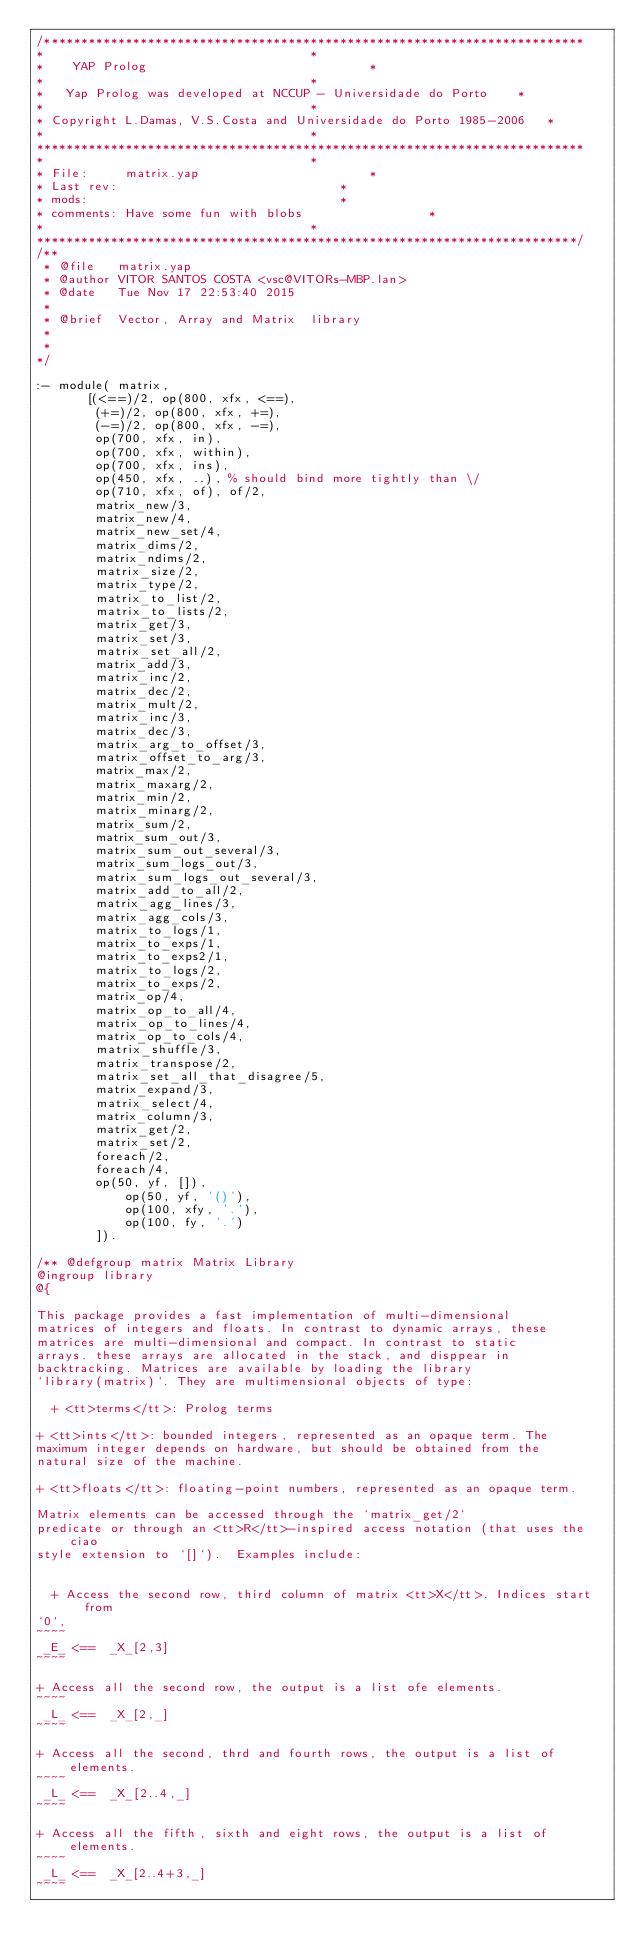<code> <loc_0><loc_0><loc_500><loc_500><_Prolog_>/*************************************************************************
*									 *
*	 YAP Prolog 							 *
*									 *
*	Yap Prolog was developed at NCCUP - Universidade do Porto	 *
*									 *
* Copyright L.Damas, V.S.Costa and Universidade do Porto 1985-2006	 *
*									 *
**************************************************************************
*									 *
* File:		matrix.yap						 *
* Last rev:								 *
* mods:									 *
* comments:	Have some fun with blobs				 *
*									 *
*************************************************************************/
/**
 * @file   matrix.yap
 * @author VITOR SANTOS COSTA <vsc@VITORs-MBP.lan>
 * @date   Tue Nov 17 22:53:40 2015
 *
 * @brief  Vector, Array and Matrix  library
 *
 *
*/

:- module( matrix,
	   [(<==)/2, op(800, xfx, <==),
	    (+=)/2, op(800, xfx, +=),
	    (-=)/2, op(800, xfx, -=),
	    op(700, xfx, in),
	    op(700, xfx, within),
	    op(700, xfx, ins),
        op(450, xfx, ..), % should bind more tightly than \/
	    op(710, xfx, of), of/2,
	    matrix_new/3,
	    matrix_new/4,
	    matrix_new_set/4,
	    matrix_dims/2,
	    matrix_ndims/2,
	    matrix_size/2,
	    matrix_type/2,
	    matrix_to_list/2,
	    matrix_to_lists/2,
	    matrix_get/3,
	    matrix_set/3,
	    matrix_set_all/2,
	    matrix_add/3,
	    matrix_inc/2,
	    matrix_dec/2,
	    matrix_mult/2,
	    matrix_inc/3,
	    matrix_dec/3,
	    matrix_arg_to_offset/3,
	    matrix_offset_to_arg/3,
	    matrix_max/2,
	    matrix_maxarg/2,
	    matrix_min/2,
	    matrix_minarg/2,
	    matrix_sum/2,
	    matrix_sum_out/3,
	    matrix_sum_out_several/3,
	    matrix_sum_logs_out/3,
	    matrix_sum_logs_out_several/3,
	    matrix_add_to_all/2,
	    matrix_agg_lines/3,
	    matrix_agg_cols/3,
	    matrix_to_logs/1,
	    matrix_to_exps/1,
	    matrix_to_exps2/1,
	    matrix_to_logs/2,
	    matrix_to_exps/2,
	    matrix_op/4,
	    matrix_op_to_all/4,
	    matrix_op_to_lines/4,
	    matrix_op_to_cols/4,
	    matrix_shuffle/3,
	    matrix_transpose/2,
	    matrix_set_all_that_disagree/5,
	    matrix_expand/3,
	    matrix_select/4,
	    matrix_column/3,
	    matrix_get/2,
	    matrix_set/2,
	    foreach/2,
	    foreach/4,
	    op(50, yf, []),
            op(50, yf, '()'),
            op(100, xfy, '.'),
            op(100, fy, '.')
	    ]).

/** @defgroup matrix Matrix Library
@ingroup library
@{

This package provides a fast implementation of multi-dimensional
matrices of integers and floats. In contrast to dynamic arrays, these
matrices are multi-dimensional and compact. In contrast to static
arrays. these arrays are allocated in the stack, and disppear in
backtracking. Matrices are available by loading the library
`library(matrix)`. They are multimensional objects of type:

  + <tt>terms</tt>: Prolog terms

+ <tt>ints</tt>: bounded integers, represented as an opaque term. The
maximum integer depends on hardware, but should be obtained from the
natural size of the machine.

+ <tt>floats</tt>: floating-point numbers, represented as an opaque term.

Matrix elements can be accessed through the `matrix_get/2`
predicate or through an <tt>R</tt>-inspired access notation (that uses the ciao
style extension to `[]`).  Examples include:


  + Access the second row, third column of matrix <tt>X</tt>. Indices start from
`0`,
~~~~
 _E_ <==  _X_[2,3]
~~~~

+ Access all the second row, the output is a list ofe elements.
~~~~
 _L_ <==  _X_[2,_]
~~~~

+ Access all the second, thrd and fourth rows, the output is a list of elements.
~~~~
 _L_ <==  _X_[2..4,_]
~~~~

+ Access all the fifth, sixth and eight rows, the output is a list of elements.
~~~~
 _L_ <==  _X_[2..4+3,_]
~~~~
</code> 